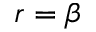<formula> <loc_0><loc_0><loc_500><loc_500>r = \beta</formula> 